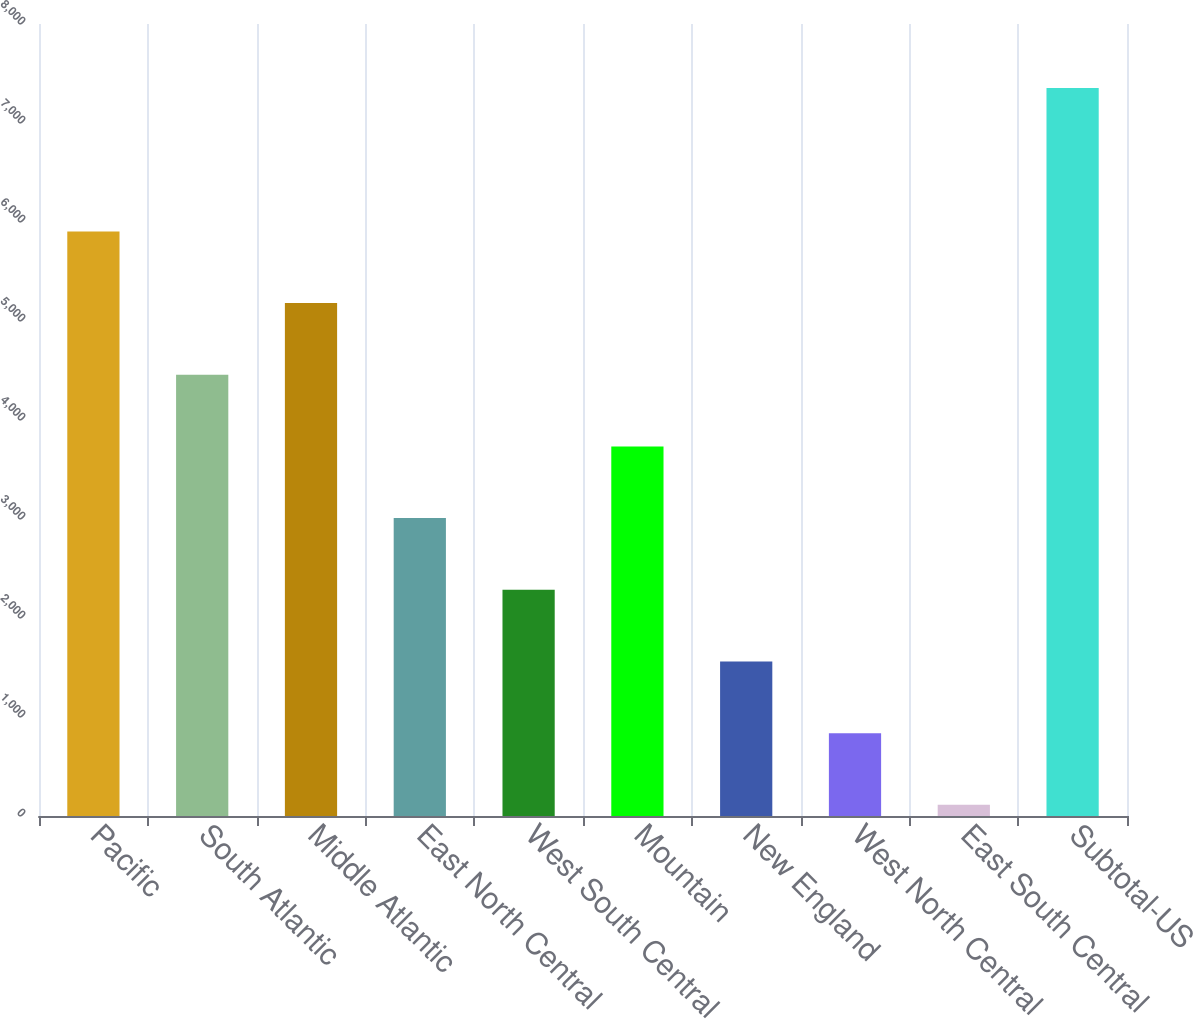Convert chart to OTSL. <chart><loc_0><loc_0><loc_500><loc_500><bar_chart><fcel>Pacific<fcel>South Atlantic<fcel>Middle Atlantic<fcel>East North Central<fcel>West South Central<fcel>Mountain<fcel>New England<fcel>West North Central<fcel>East South Central<fcel>Subtotal-US<nl><fcel>5905<fcel>4457<fcel>5181<fcel>3009<fcel>2285<fcel>3733<fcel>1561<fcel>837<fcel>113<fcel>7353<nl></chart> 